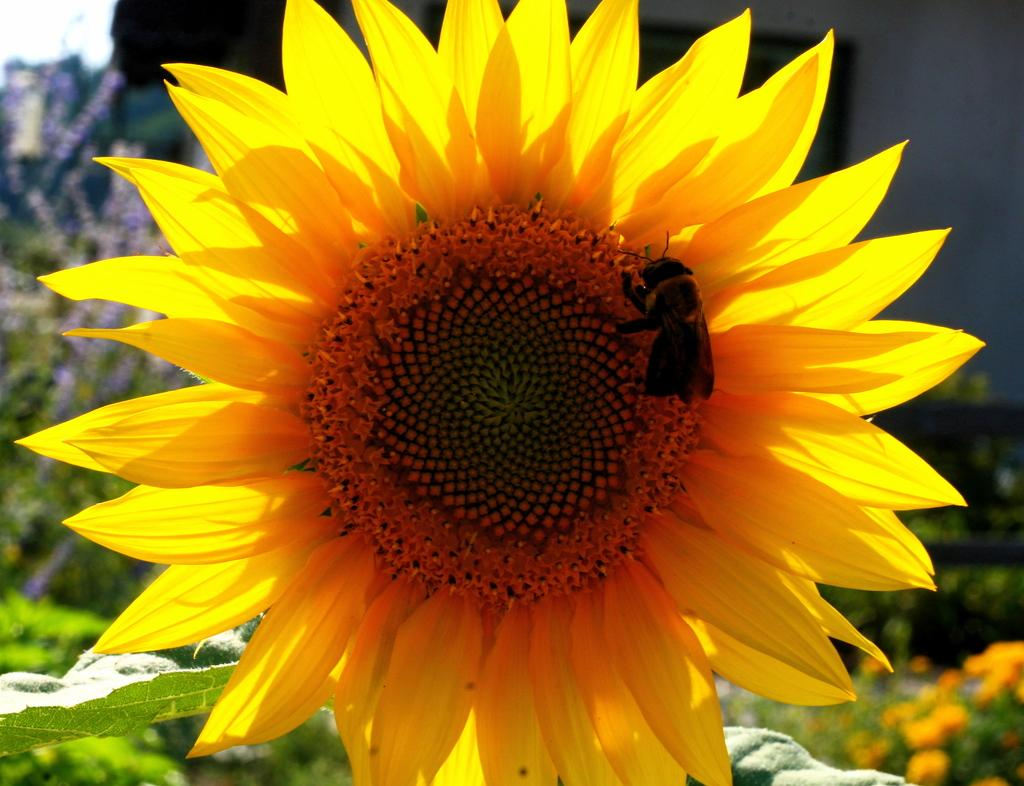What is the main subject of the image? There is an insect on a sunflower in the image. What can be seen in the background of the image? There are plants and flowers in the background of the image. What type of lettuce is growing next to the insect in the image? There is no lettuce present in the image; it features an insect on a sunflower and plants and flowers in the background. 